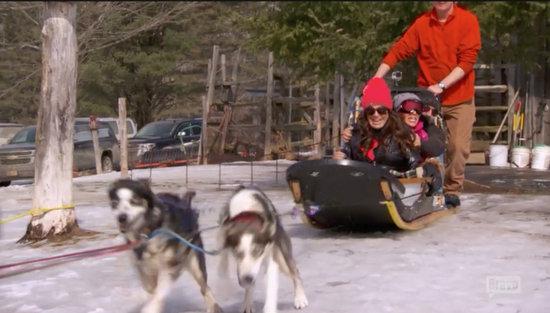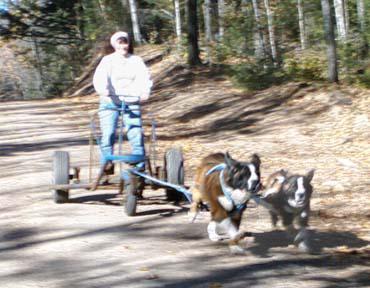The first image is the image on the left, the second image is the image on the right. Examine the images to the left and right. Is the description "In the left image, two dogs are pulling a sled on the snow with a rope extending to the left." accurate? Answer yes or no. Yes. The first image is the image on the left, the second image is the image on the right. Given the left and right images, does the statement "All of the dogs are running in snow." hold true? Answer yes or no. No. 